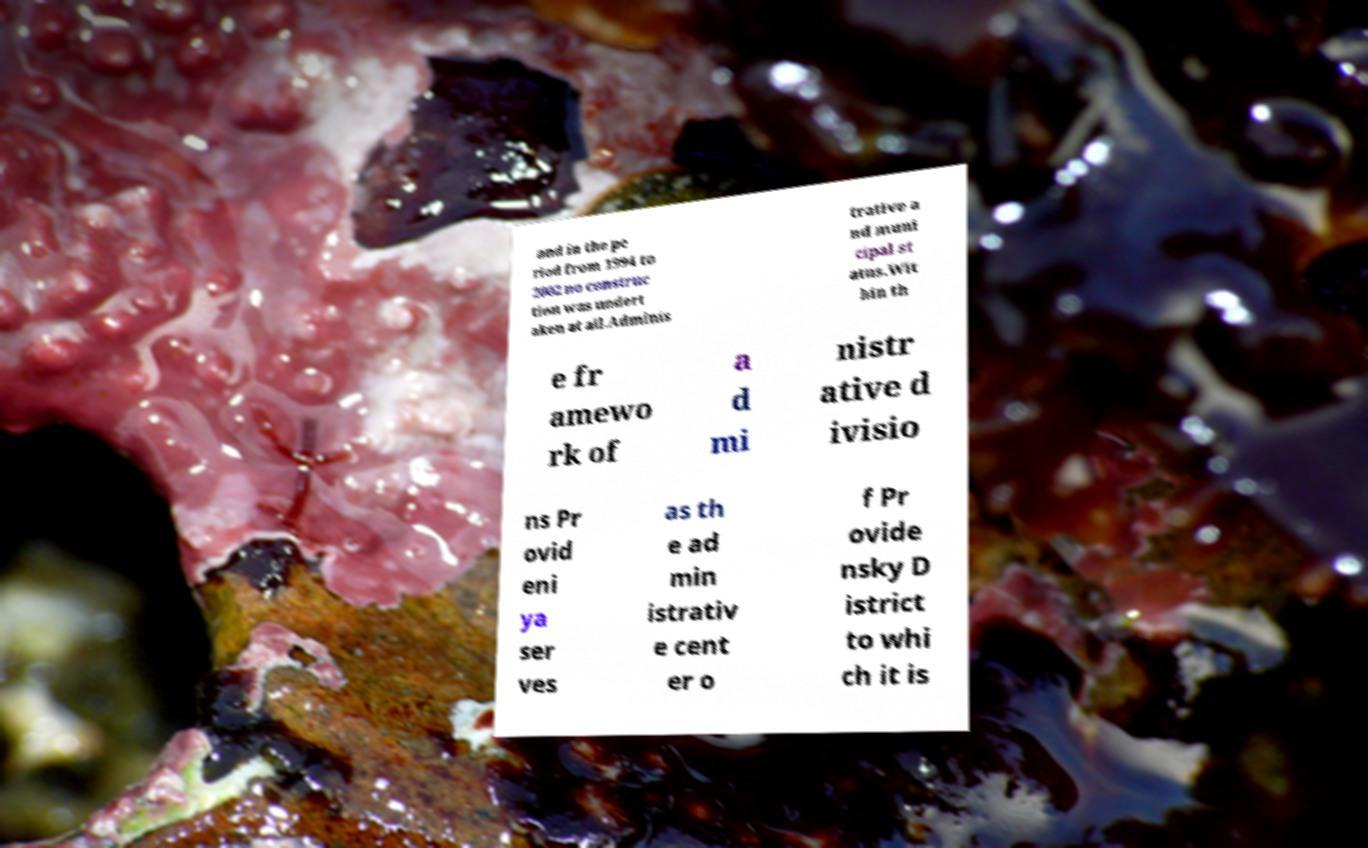For documentation purposes, I need the text within this image transcribed. Could you provide that? and in the pe riod from 1994 to 2002 no construc tion was undert aken at all.Adminis trative a nd muni cipal st atus.Wit hin th e fr amewo rk of a d mi nistr ative d ivisio ns Pr ovid eni ya ser ves as th e ad min istrativ e cent er o f Pr ovide nsky D istrict to whi ch it is 